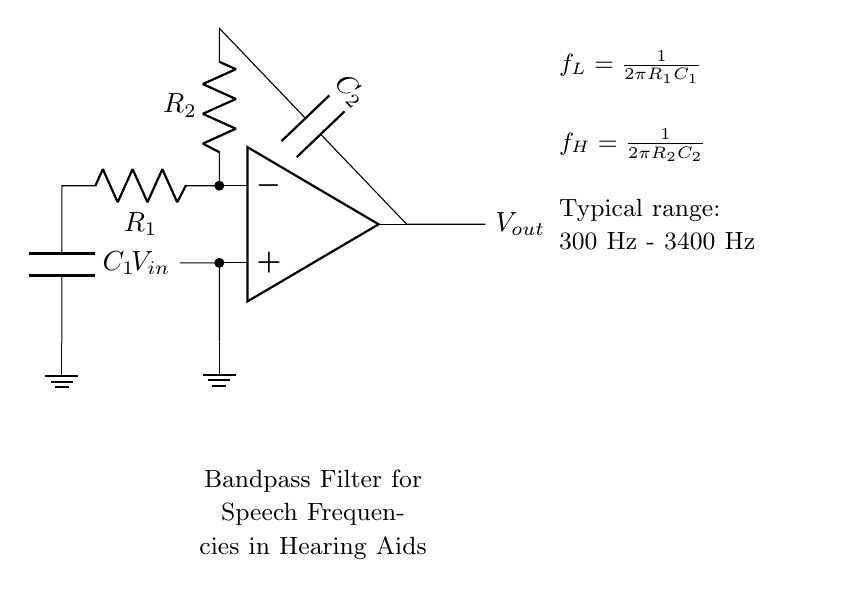What type of filter is represented in this circuit? The circuit is a bandpass filter, which is indicated in the text below the circuit diagram. A bandpass filter allows frequencies within a certain range to pass while attenuating frequencies outside this range.
Answer: bandpass filter What are the resistances used in the circuit? The resistances in the circuit are labeled as R1 and R2. R1 is connected to the inverting input and is part of the low-frequency cutoff, while R2 is connected to the non-inverting input for the high-frequency cutoff.
Answer: R1, R2 What frequency range does this filter enhance? The text in the diagram indicates that the typical range of frequencies enhanced by this filter is from 300 Hz to 3400 Hz. This range includes audible speech frequencies, which the hearing aid aims to enhance.
Answer: 300 Hz - 3400 Hz How does the low cutoff frequency relate to R1 and C1? The low cutoff frequency fL is defined by the formula fL = 1/(2πR1C1). This shows that increasing R1 or C1 will lower the cutoff frequency, allowing more lower frequencies to pass through.
Answer: fL = 1/(2πR1C1) What component is connected at the output of the op-amp? The output of the op-amp connects to the output node, represented as Vout. This is where the enhanced signal for further processing or outputting is taken from.
Answer: Vout What is the purpose of capacitor C2 in this circuit? Capacitor C2 is part of the high-frequency response, as indicated by the connected resistive component R2. Its role is to prevent high frequencies above a certain range from passing through, creating the bandpass effect.
Answer: High-frequency cutoff What does the op-amp in the circuit do? The op-amp serves as an amplifier that processes the input signal, applying gain to the frequencies within the designated band while filtering out others. It is essential for enhancing the desired speech range in hearing aids.
Answer: Amplifier 